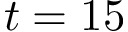<formula> <loc_0><loc_0><loc_500><loc_500>t = 1 5</formula> 